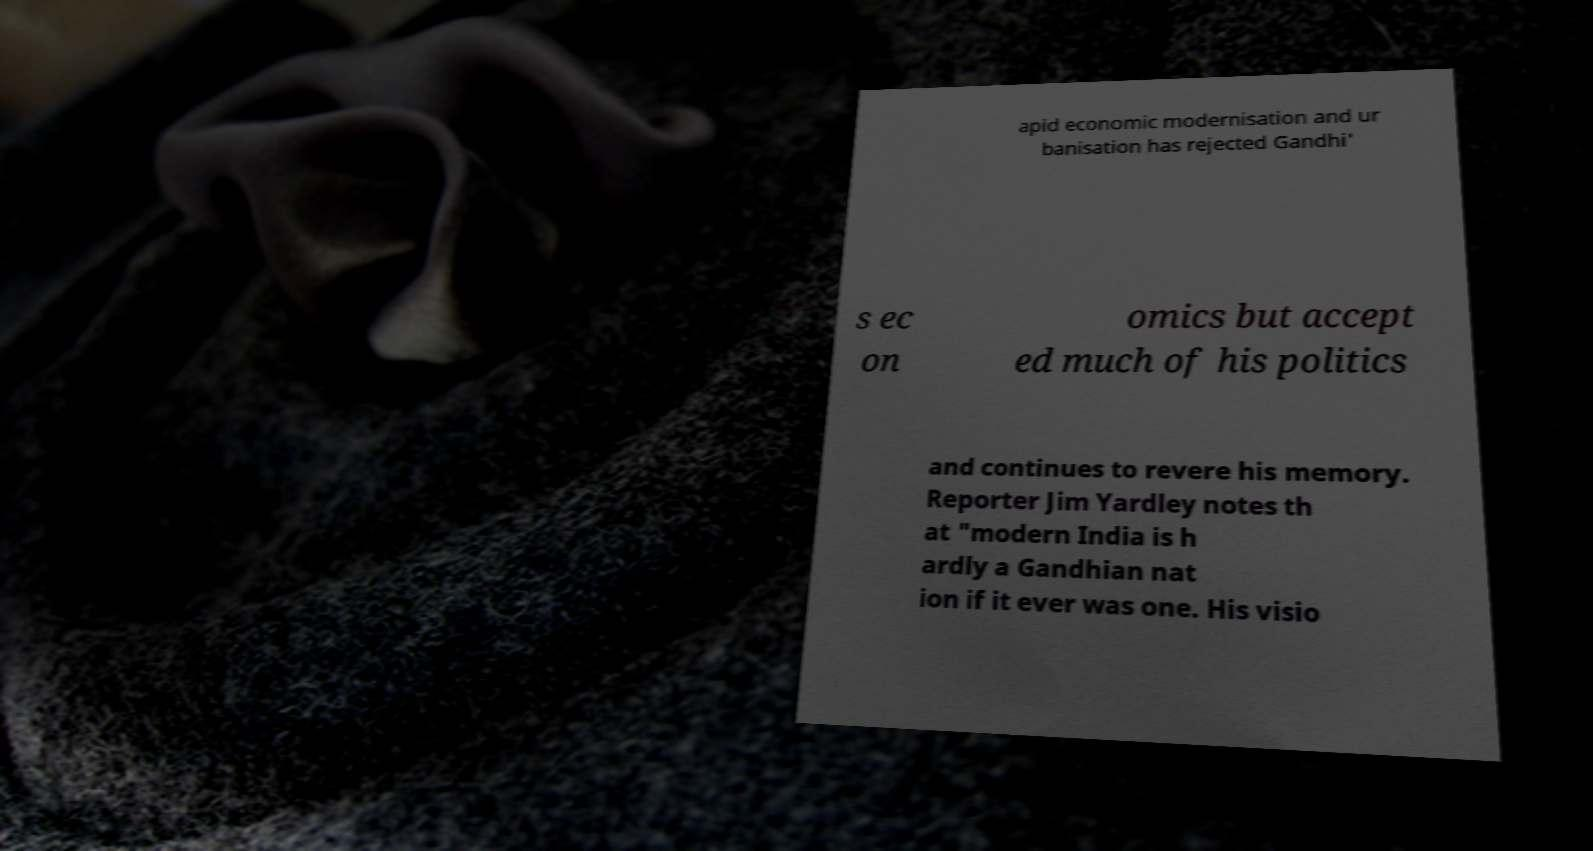Could you assist in decoding the text presented in this image and type it out clearly? apid economic modernisation and ur banisation has rejected Gandhi' s ec on omics but accept ed much of his politics and continues to revere his memory. Reporter Jim Yardley notes th at "modern India is h ardly a Gandhian nat ion if it ever was one. His visio 